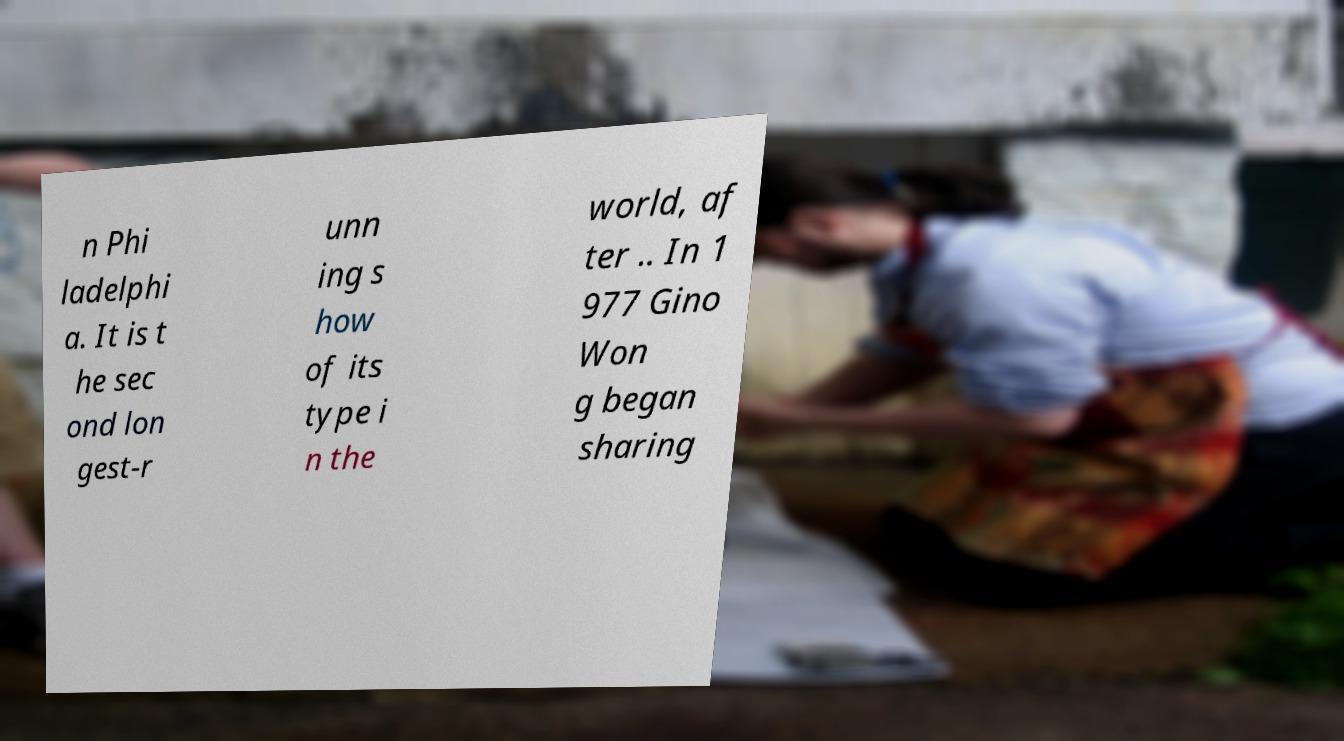Could you extract and type out the text from this image? n Phi ladelphi a. It is t he sec ond lon gest-r unn ing s how of its type i n the world, af ter .. In 1 977 Gino Won g began sharing 